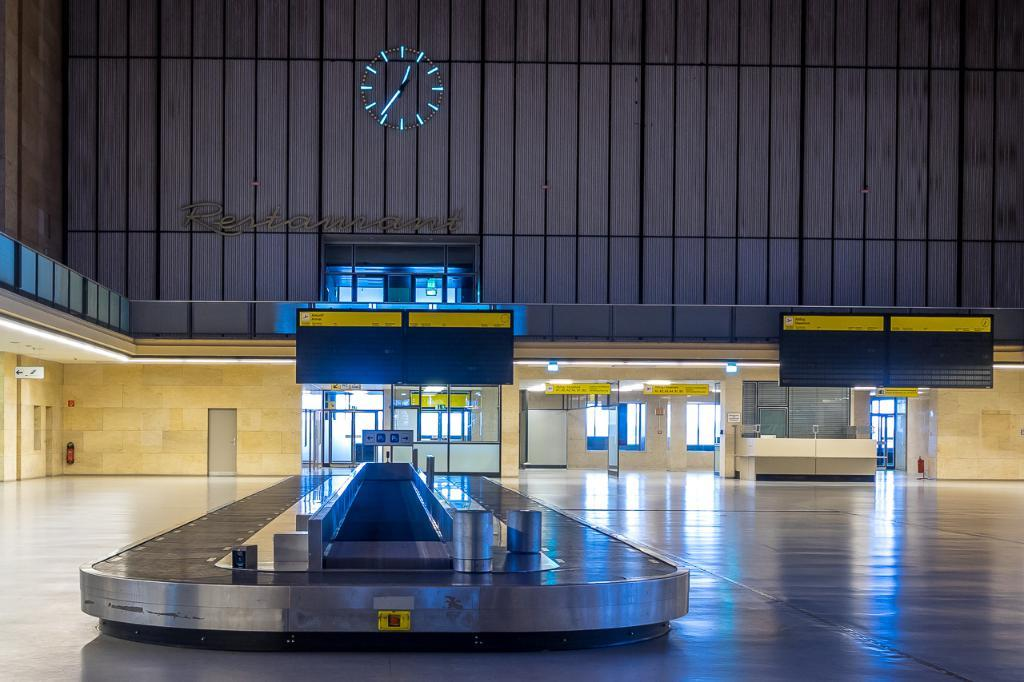What is located on the floor in the image? There is an object on the floor in the image. What can be seen in the distance in the image? There is a building in the background of the image. What features are present on the building or nearby structures? There are doors and windows in the image. How many girls are playing with the finger in the image? There are no girls or fingers present in the image. 